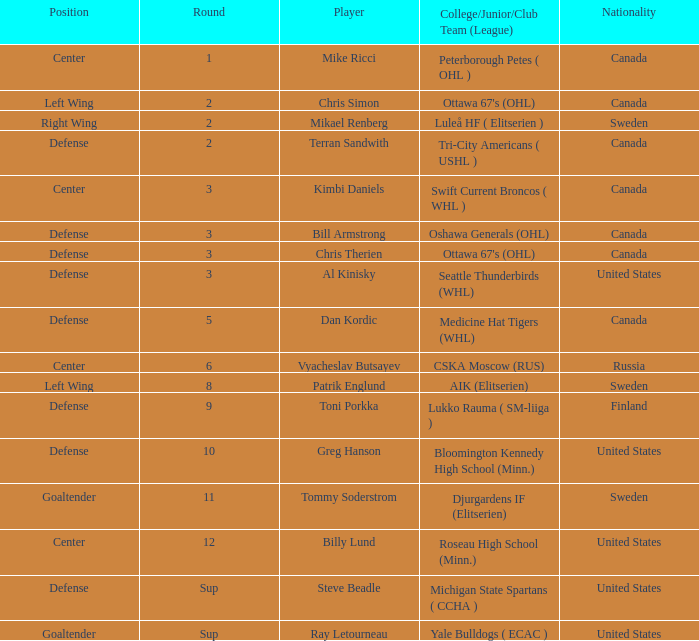What is the school that hosts mikael renberg Luleå HF ( Elitserien ). 